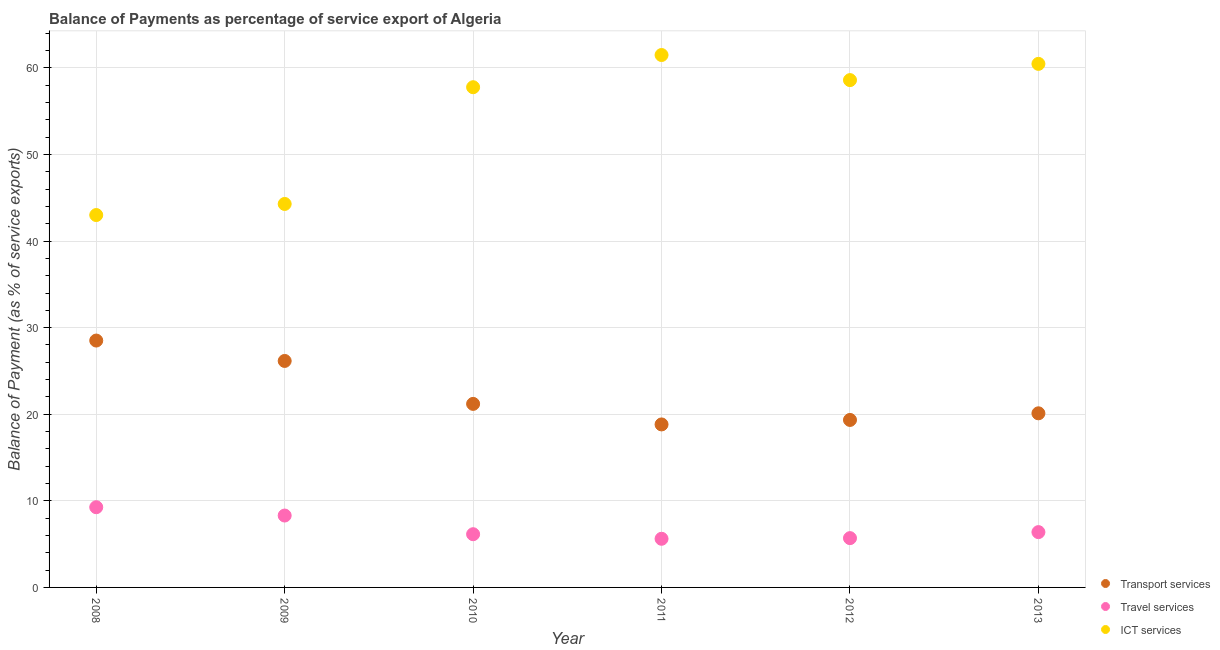How many different coloured dotlines are there?
Your response must be concise. 3. Is the number of dotlines equal to the number of legend labels?
Provide a short and direct response. Yes. What is the balance of payment of transport services in 2008?
Your answer should be very brief. 28.51. Across all years, what is the maximum balance of payment of transport services?
Keep it short and to the point. 28.51. Across all years, what is the minimum balance of payment of transport services?
Make the answer very short. 18.82. In which year was the balance of payment of transport services minimum?
Ensure brevity in your answer.  2011. What is the total balance of payment of transport services in the graph?
Your response must be concise. 134.13. What is the difference between the balance of payment of ict services in 2008 and that in 2010?
Provide a succinct answer. -14.76. What is the difference between the balance of payment of travel services in 2010 and the balance of payment of transport services in 2013?
Your answer should be compact. -13.96. What is the average balance of payment of travel services per year?
Provide a succinct answer. 6.9. In the year 2011, what is the difference between the balance of payment of ict services and balance of payment of transport services?
Make the answer very short. 42.66. What is the ratio of the balance of payment of travel services in 2012 to that in 2013?
Keep it short and to the point. 0.89. Is the balance of payment of transport services in 2011 less than that in 2012?
Your answer should be compact. Yes. Is the difference between the balance of payment of transport services in 2009 and 2010 greater than the difference between the balance of payment of travel services in 2009 and 2010?
Your answer should be compact. Yes. What is the difference between the highest and the second highest balance of payment of transport services?
Provide a short and direct response. 2.35. What is the difference between the highest and the lowest balance of payment of travel services?
Provide a succinct answer. 3.65. In how many years, is the balance of payment of travel services greater than the average balance of payment of travel services taken over all years?
Your answer should be very brief. 2. Is it the case that in every year, the sum of the balance of payment of transport services and balance of payment of travel services is greater than the balance of payment of ict services?
Give a very brief answer. No. How many dotlines are there?
Make the answer very short. 3. What is the difference between two consecutive major ticks on the Y-axis?
Your answer should be compact. 10. Does the graph contain grids?
Provide a succinct answer. Yes. What is the title of the graph?
Provide a short and direct response. Balance of Payments as percentage of service export of Algeria. Does "Agricultural raw materials" appear as one of the legend labels in the graph?
Offer a terse response. No. What is the label or title of the X-axis?
Your response must be concise. Year. What is the label or title of the Y-axis?
Your answer should be very brief. Balance of Payment (as % of service exports). What is the Balance of Payment (as % of service exports) in Transport services in 2008?
Your answer should be very brief. 28.51. What is the Balance of Payment (as % of service exports) in Travel services in 2008?
Make the answer very short. 9.26. What is the Balance of Payment (as % of service exports) of ICT services in 2008?
Your answer should be compact. 43. What is the Balance of Payment (as % of service exports) of Transport services in 2009?
Your response must be concise. 26.15. What is the Balance of Payment (as % of service exports) of Travel services in 2009?
Offer a very short reply. 8.3. What is the Balance of Payment (as % of service exports) in ICT services in 2009?
Your response must be concise. 44.28. What is the Balance of Payment (as % of service exports) of Transport services in 2010?
Your response must be concise. 21.2. What is the Balance of Payment (as % of service exports) of Travel services in 2010?
Ensure brevity in your answer.  6.15. What is the Balance of Payment (as % of service exports) in ICT services in 2010?
Give a very brief answer. 57.77. What is the Balance of Payment (as % of service exports) of Transport services in 2011?
Keep it short and to the point. 18.82. What is the Balance of Payment (as % of service exports) in Travel services in 2011?
Your answer should be very brief. 5.62. What is the Balance of Payment (as % of service exports) of ICT services in 2011?
Offer a terse response. 61.48. What is the Balance of Payment (as % of service exports) of Transport services in 2012?
Make the answer very short. 19.34. What is the Balance of Payment (as % of service exports) in Travel services in 2012?
Make the answer very short. 5.69. What is the Balance of Payment (as % of service exports) of ICT services in 2012?
Offer a very short reply. 58.59. What is the Balance of Payment (as % of service exports) in Transport services in 2013?
Make the answer very short. 20.11. What is the Balance of Payment (as % of service exports) in Travel services in 2013?
Offer a terse response. 6.39. What is the Balance of Payment (as % of service exports) in ICT services in 2013?
Offer a very short reply. 60.46. Across all years, what is the maximum Balance of Payment (as % of service exports) in Transport services?
Keep it short and to the point. 28.51. Across all years, what is the maximum Balance of Payment (as % of service exports) in Travel services?
Offer a very short reply. 9.26. Across all years, what is the maximum Balance of Payment (as % of service exports) of ICT services?
Keep it short and to the point. 61.48. Across all years, what is the minimum Balance of Payment (as % of service exports) in Transport services?
Provide a short and direct response. 18.82. Across all years, what is the minimum Balance of Payment (as % of service exports) in Travel services?
Provide a short and direct response. 5.62. Across all years, what is the minimum Balance of Payment (as % of service exports) of ICT services?
Offer a very short reply. 43. What is the total Balance of Payment (as % of service exports) of Transport services in the graph?
Offer a terse response. 134.13. What is the total Balance of Payment (as % of service exports) of Travel services in the graph?
Your answer should be compact. 41.41. What is the total Balance of Payment (as % of service exports) in ICT services in the graph?
Provide a short and direct response. 325.58. What is the difference between the Balance of Payment (as % of service exports) in Transport services in 2008 and that in 2009?
Your answer should be very brief. 2.35. What is the difference between the Balance of Payment (as % of service exports) in Travel services in 2008 and that in 2009?
Keep it short and to the point. 0.96. What is the difference between the Balance of Payment (as % of service exports) in ICT services in 2008 and that in 2009?
Give a very brief answer. -1.28. What is the difference between the Balance of Payment (as % of service exports) of Transport services in 2008 and that in 2010?
Your answer should be compact. 7.31. What is the difference between the Balance of Payment (as % of service exports) in Travel services in 2008 and that in 2010?
Your answer should be very brief. 3.12. What is the difference between the Balance of Payment (as % of service exports) of ICT services in 2008 and that in 2010?
Make the answer very short. -14.76. What is the difference between the Balance of Payment (as % of service exports) in Transport services in 2008 and that in 2011?
Give a very brief answer. 9.69. What is the difference between the Balance of Payment (as % of service exports) in Travel services in 2008 and that in 2011?
Ensure brevity in your answer.  3.65. What is the difference between the Balance of Payment (as % of service exports) of ICT services in 2008 and that in 2011?
Your answer should be compact. -18.48. What is the difference between the Balance of Payment (as % of service exports) of Transport services in 2008 and that in 2012?
Your answer should be very brief. 9.17. What is the difference between the Balance of Payment (as % of service exports) in Travel services in 2008 and that in 2012?
Your answer should be compact. 3.57. What is the difference between the Balance of Payment (as % of service exports) of ICT services in 2008 and that in 2012?
Your answer should be very brief. -15.58. What is the difference between the Balance of Payment (as % of service exports) of Transport services in 2008 and that in 2013?
Your answer should be very brief. 8.4. What is the difference between the Balance of Payment (as % of service exports) in Travel services in 2008 and that in 2013?
Provide a short and direct response. 2.88. What is the difference between the Balance of Payment (as % of service exports) in ICT services in 2008 and that in 2013?
Provide a succinct answer. -17.46. What is the difference between the Balance of Payment (as % of service exports) of Transport services in 2009 and that in 2010?
Your response must be concise. 4.96. What is the difference between the Balance of Payment (as % of service exports) of Travel services in 2009 and that in 2010?
Provide a succinct answer. 2.16. What is the difference between the Balance of Payment (as % of service exports) of ICT services in 2009 and that in 2010?
Ensure brevity in your answer.  -13.48. What is the difference between the Balance of Payment (as % of service exports) of Transport services in 2009 and that in 2011?
Offer a very short reply. 7.33. What is the difference between the Balance of Payment (as % of service exports) in Travel services in 2009 and that in 2011?
Ensure brevity in your answer.  2.68. What is the difference between the Balance of Payment (as % of service exports) of ICT services in 2009 and that in 2011?
Ensure brevity in your answer.  -17.2. What is the difference between the Balance of Payment (as % of service exports) in Transport services in 2009 and that in 2012?
Your answer should be very brief. 6.81. What is the difference between the Balance of Payment (as % of service exports) in Travel services in 2009 and that in 2012?
Offer a terse response. 2.61. What is the difference between the Balance of Payment (as % of service exports) of ICT services in 2009 and that in 2012?
Provide a short and direct response. -14.3. What is the difference between the Balance of Payment (as % of service exports) in Transport services in 2009 and that in 2013?
Your response must be concise. 6.05. What is the difference between the Balance of Payment (as % of service exports) of Travel services in 2009 and that in 2013?
Provide a short and direct response. 1.91. What is the difference between the Balance of Payment (as % of service exports) in ICT services in 2009 and that in 2013?
Your answer should be compact. -16.18. What is the difference between the Balance of Payment (as % of service exports) of Transport services in 2010 and that in 2011?
Your answer should be very brief. 2.37. What is the difference between the Balance of Payment (as % of service exports) in Travel services in 2010 and that in 2011?
Offer a terse response. 0.53. What is the difference between the Balance of Payment (as % of service exports) in ICT services in 2010 and that in 2011?
Make the answer very short. -3.72. What is the difference between the Balance of Payment (as % of service exports) of Transport services in 2010 and that in 2012?
Provide a short and direct response. 1.85. What is the difference between the Balance of Payment (as % of service exports) in Travel services in 2010 and that in 2012?
Ensure brevity in your answer.  0.45. What is the difference between the Balance of Payment (as % of service exports) in ICT services in 2010 and that in 2012?
Make the answer very short. -0.82. What is the difference between the Balance of Payment (as % of service exports) in Transport services in 2010 and that in 2013?
Provide a short and direct response. 1.09. What is the difference between the Balance of Payment (as % of service exports) in Travel services in 2010 and that in 2013?
Provide a short and direct response. -0.24. What is the difference between the Balance of Payment (as % of service exports) of ICT services in 2010 and that in 2013?
Your answer should be compact. -2.7. What is the difference between the Balance of Payment (as % of service exports) in Transport services in 2011 and that in 2012?
Make the answer very short. -0.52. What is the difference between the Balance of Payment (as % of service exports) of Travel services in 2011 and that in 2012?
Your answer should be very brief. -0.08. What is the difference between the Balance of Payment (as % of service exports) in ICT services in 2011 and that in 2012?
Provide a short and direct response. 2.9. What is the difference between the Balance of Payment (as % of service exports) in Transport services in 2011 and that in 2013?
Your answer should be compact. -1.28. What is the difference between the Balance of Payment (as % of service exports) in Travel services in 2011 and that in 2013?
Your response must be concise. -0.77. What is the difference between the Balance of Payment (as % of service exports) of ICT services in 2011 and that in 2013?
Provide a short and direct response. 1.02. What is the difference between the Balance of Payment (as % of service exports) of Transport services in 2012 and that in 2013?
Ensure brevity in your answer.  -0.77. What is the difference between the Balance of Payment (as % of service exports) of Travel services in 2012 and that in 2013?
Provide a short and direct response. -0.69. What is the difference between the Balance of Payment (as % of service exports) of ICT services in 2012 and that in 2013?
Ensure brevity in your answer.  -1.87. What is the difference between the Balance of Payment (as % of service exports) in Transport services in 2008 and the Balance of Payment (as % of service exports) in Travel services in 2009?
Provide a succinct answer. 20.21. What is the difference between the Balance of Payment (as % of service exports) of Transport services in 2008 and the Balance of Payment (as % of service exports) of ICT services in 2009?
Provide a short and direct response. -15.77. What is the difference between the Balance of Payment (as % of service exports) in Travel services in 2008 and the Balance of Payment (as % of service exports) in ICT services in 2009?
Offer a terse response. -35.02. What is the difference between the Balance of Payment (as % of service exports) in Transport services in 2008 and the Balance of Payment (as % of service exports) in Travel services in 2010?
Give a very brief answer. 22.36. What is the difference between the Balance of Payment (as % of service exports) of Transport services in 2008 and the Balance of Payment (as % of service exports) of ICT services in 2010?
Make the answer very short. -29.26. What is the difference between the Balance of Payment (as % of service exports) in Travel services in 2008 and the Balance of Payment (as % of service exports) in ICT services in 2010?
Keep it short and to the point. -48.5. What is the difference between the Balance of Payment (as % of service exports) of Transport services in 2008 and the Balance of Payment (as % of service exports) of Travel services in 2011?
Ensure brevity in your answer.  22.89. What is the difference between the Balance of Payment (as % of service exports) in Transport services in 2008 and the Balance of Payment (as % of service exports) in ICT services in 2011?
Offer a terse response. -32.97. What is the difference between the Balance of Payment (as % of service exports) of Travel services in 2008 and the Balance of Payment (as % of service exports) of ICT services in 2011?
Offer a very short reply. -52.22. What is the difference between the Balance of Payment (as % of service exports) of Transport services in 2008 and the Balance of Payment (as % of service exports) of Travel services in 2012?
Ensure brevity in your answer.  22.82. What is the difference between the Balance of Payment (as % of service exports) of Transport services in 2008 and the Balance of Payment (as % of service exports) of ICT services in 2012?
Keep it short and to the point. -30.08. What is the difference between the Balance of Payment (as % of service exports) of Travel services in 2008 and the Balance of Payment (as % of service exports) of ICT services in 2012?
Provide a short and direct response. -49.32. What is the difference between the Balance of Payment (as % of service exports) in Transport services in 2008 and the Balance of Payment (as % of service exports) in Travel services in 2013?
Provide a short and direct response. 22.12. What is the difference between the Balance of Payment (as % of service exports) in Transport services in 2008 and the Balance of Payment (as % of service exports) in ICT services in 2013?
Your answer should be compact. -31.95. What is the difference between the Balance of Payment (as % of service exports) of Travel services in 2008 and the Balance of Payment (as % of service exports) of ICT services in 2013?
Offer a terse response. -51.2. What is the difference between the Balance of Payment (as % of service exports) of Transport services in 2009 and the Balance of Payment (as % of service exports) of Travel services in 2010?
Provide a short and direct response. 20.01. What is the difference between the Balance of Payment (as % of service exports) in Transport services in 2009 and the Balance of Payment (as % of service exports) in ICT services in 2010?
Provide a short and direct response. -31.61. What is the difference between the Balance of Payment (as % of service exports) of Travel services in 2009 and the Balance of Payment (as % of service exports) of ICT services in 2010?
Make the answer very short. -49.46. What is the difference between the Balance of Payment (as % of service exports) in Transport services in 2009 and the Balance of Payment (as % of service exports) in Travel services in 2011?
Give a very brief answer. 20.54. What is the difference between the Balance of Payment (as % of service exports) in Transport services in 2009 and the Balance of Payment (as % of service exports) in ICT services in 2011?
Make the answer very short. -35.33. What is the difference between the Balance of Payment (as % of service exports) in Travel services in 2009 and the Balance of Payment (as % of service exports) in ICT services in 2011?
Give a very brief answer. -53.18. What is the difference between the Balance of Payment (as % of service exports) of Transport services in 2009 and the Balance of Payment (as % of service exports) of Travel services in 2012?
Your answer should be compact. 20.46. What is the difference between the Balance of Payment (as % of service exports) of Transport services in 2009 and the Balance of Payment (as % of service exports) of ICT services in 2012?
Your answer should be compact. -32.43. What is the difference between the Balance of Payment (as % of service exports) in Travel services in 2009 and the Balance of Payment (as % of service exports) in ICT services in 2012?
Your answer should be compact. -50.28. What is the difference between the Balance of Payment (as % of service exports) of Transport services in 2009 and the Balance of Payment (as % of service exports) of Travel services in 2013?
Give a very brief answer. 19.77. What is the difference between the Balance of Payment (as % of service exports) in Transport services in 2009 and the Balance of Payment (as % of service exports) in ICT services in 2013?
Your response must be concise. -34.31. What is the difference between the Balance of Payment (as % of service exports) in Travel services in 2009 and the Balance of Payment (as % of service exports) in ICT services in 2013?
Keep it short and to the point. -52.16. What is the difference between the Balance of Payment (as % of service exports) of Transport services in 2010 and the Balance of Payment (as % of service exports) of Travel services in 2011?
Provide a short and direct response. 15.58. What is the difference between the Balance of Payment (as % of service exports) in Transport services in 2010 and the Balance of Payment (as % of service exports) in ICT services in 2011?
Provide a short and direct response. -40.29. What is the difference between the Balance of Payment (as % of service exports) of Travel services in 2010 and the Balance of Payment (as % of service exports) of ICT services in 2011?
Provide a short and direct response. -55.34. What is the difference between the Balance of Payment (as % of service exports) in Transport services in 2010 and the Balance of Payment (as % of service exports) in Travel services in 2012?
Your response must be concise. 15.5. What is the difference between the Balance of Payment (as % of service exports) in Transport services in 2010 and the Balance of Payment (as % of service exports) in ICT services in 2012?
Offer a very short reply. -37.39. What is the difference between the Balance of Payment (as % of service exports) in Travel services in 2010 and the Balance of Payment (as % of service exports) in ICT services in 2012?
Provide a succinct answer. -52.44. What is the difference between the Balance of Payment (as % of service exports) in Transport services in 2010 and the Balance of Payment (as % of service exports) in Travel services in 2013?
Offer a terse response. 14.81. What is the difference between the Balance of Payment (as % of service exports) of Transport services in 2010 and the Balance of Payment (as % of service exports) of ICT services in 2013?
Keep it short and to the point. -39.27. What is the difference between the Balance of Payment (as % of service exports) of Travel services in 2010 and the Balance of Payment (as % of service exports) of ICT services in 2013?
Keep it short and to the point. -54.32. What is the difference between the Balance of Payment (as % of service exports) in Transport services in 2011 and the Balance of Payment (as % of service exports) in Travel services in 2012?
Offer a very short reply. 13.13. What is the difference between the Balance of Payment (as % of service exports) in Transport services in 2011 and the Balance of Payment (as % of service exports) in ICT services in 2012?
Your response must be concise. -39.76. What is the difference between the Balance of Payment (as % of service exports) in Travel services in 2011 and the Balance of Payment (as % of service exports) in ICT services in 2012?
Make the answer very short. -52.97. What is the difference between the Balance of Payment (as % of service exports) in Transport services in 2011 and the Balance of Payment (as % of service exports) in Travel services in 2013?
Your answer should be very brief. 12.44. What is the difference between the Balance of Payment (as % of service exports) in Transport services in 2011 and the Balance of Payment (as % of service exports) in ICT services in 2013?
Your answer should be very brief. -41.64. What is the difference between the Balance of Payment (as % of service exports) of Travel services in 2011 and the Balance of Payment (as % of service exports) of ICT services in 2013?
Ensure brevity in your answer.  -54.84. What is the difference between the Balance of Payment (as % of service exports) in Transport services in 2012 and the Balance of Payment (as % of service exports) in Travel services in 2013?
Your response must be concise. 12.95. What is the difference between the Balance of Payment (as % of service exports) of Transport services in 2012 and the Balance of Payment (as % of service exports) of ICT services in 2013?
Offer a very short reply. -41.12. What is the difference between the Balance of Payment (as % of service exports) of Travel services in 2012 and the Balance of Payment (as % of service exports) of ICT services in 2013?
Your answer should be very brief. -54.77. What is the average Balance of Payment (as % of service exports) of Transport services per year?
Make the answer very short. 22.36. What is the average Balance of Payment (as % of service exports) in Travel services per year?
Give a very brief answer. 6.9. What is the average Balance of Payment (as % of service exports) in ICT services per year?
Give a very brief answer. 54.26. In the year 2008, what is the difference between the Balance of Payment (as % of service exports) in Transport services and Balance of Payment (as % of service exports) in Travel services?
Make the answer very short. 19.25. In the year 2008, what is the difference between the Balance of Payment (as % of service exports) of Transport services and Balance of Payment (as % of service exports) of ICT services?
Offer a terse response. -14.49. In the year 2008, what is the difference between the Balance of Payment (as % of service exports) in Travel services and Balance of Payment (as % of service exports) in ICT services?
Give a very brief answer. -33.74. In the year 2009, what is the difference between the Balance of Payment (as % of service exports) in Transport services and Balance of Payment (as % of service exports) in Travel services?
Offer a very short reply. 17.85. In the year 2009, what is the difference between the Balance of Payment (as % of service exports) of Transport services and Balance of Payment (as % of service exports) of ICT services?
Keep it short and to the point. -18.13. In the year 2009, what is the difference between the Balance of Payment (as % of service exports) of Travel services and Balance of Payment (as % of service exports) of ICT services?
Provide a succinct answer. -35.98. In the year 2010, what is the difference between the Balance of Payment (as % of service exports) of Transport services and Balance of Payment (as % of service exports) of Travel services?
Your answer should be compact. 15.05. In the year 2010, what is the difference between the Balance of Payment (as % of service exports) of Transport services and Balance of Payment (as % of service exports) of ICT services?
Provide a succinct answer. -36.57. In the year 2010, what is the difference between the Balance of Payment (as % of service exports) of Travel services and Balance of Payment (as % of service exports) of ICT services?
Give a very brief answer. -51.62. In the year 2011, what is the difference between the Balance of Payment (as % of service exports) in Transport services and Balance of Payment (as % of service exports) in Travel services?
Provide a succinct answer. 13.21. In the year 2011, what is the difference between the Balance of Payment (as % of service exports) of Transport services and Balance of Payment (as % of service exports) of ICT services?
Give a very brief answer. -42.66. In the year 2011, what is the difference between the Balance of Payment (as % of service exports) of Travel services and Balance of Payment (as % of service exports) of ICT services?
Offer a very short reply. -55.87. In the year 2012, what is the difference between the Balance of Payment (as % of service exports) in Transport services and Balance of Payment (as % of service exports) in Travel services?
Ensure brevity in your answer.  13.65. In the year 2012, what is the difference between the Balance of Payment (as % of service exports) of Transport services and Balance of Payment (as % of service exports) of ICT services?
Give a very brief answer. -39.24. In the year 2012, what is the difference between the Balance of Payment (as % of service exports) in Travel services and Balance of Payment (as % of service exports) in ICT services?
Keep it short and to the point. -52.89. In the year 2013, what is the difference between the Balance of Payment (as % of service exports) of Transport services and Balance of Payment (as % of service exports) of Travel services?
Ensure brevity in your answer.  13.72. In the year 2013, what is the difference between the Balance of Payment (as % of service exports) in Transport services and Balance of Payment (as % of service exports) in ICT services?
Provide a succinct answer. -40.35. In the year 2013, what is the difference between the Balance of Payment (as % of service exports) of Travel services and Balance of Payment (as % of service exports) of ICT services?
Your answer should be compact. -54.07. What is the ratio of the Balance of Payment (as % of service exports) of Transport services in 2008 to that in 2009?
Keep it short and to the point. 1.09. What is the ratio of the Balance of Payment (as % of service exports) of Travel services in 2008 to that in 2009?
Offer a very short reply. 1.12. What is the ratio of the Balance of Payment (as % of service exports) of ICT services in 2008 to that in 2009?
Offer a very short reply. 0.97. What is the ratio of the Balance of Payment (as % of service exports) in Transport services in 2008 to that in 2010?
Your answer should be very brief. 1.35. What is the ratio of the Balance of Payment (as % of service exports) of Travel services in 2008 to that in 2010?
Provide a succinct answer. 1.51. What is the ratio of the Balance of Payment (as % of service exports) in ICT services in 2008 to that in 2010?
Your answer should be compact. 0.74. What is the ratio of the Balance of Payment (as % of service exports) of Transport services in 2008 to that in 2011?
Your answer should be compact. 1.51. What is the ratio of the Balance of Payment (as % of service exports) in Travel services in 2008 to that in 2011?
Provide a succinct answer. 1.65. What is the ratio of the Balance of Payment (as % of service exports) of ICT services in 2008 to that in 2011?
Ensure brevity in your answer.  0.7. What is the ratio of the Balance of Payment (as % of service exports) in Transport services in 2008 to that in 2012?
Your answer should be compact. 1.47. What is the ratio of the Balance of Payment (as % of service exports) in Travel services in 2008 to that in 2012?
Keep it short and to the point. 1.63. What is the ratio of the Balance of Payment (as % of service exports) in ICT services in 2008 to that in 2012?
Your answer should be compact. 0.73. What is the ratio of the Balance of Payment (as % of service exports) in Transport services in 2008 to that in 2013?
Your answer should be very brief. 1.42. What is the ratio of the Balance of Payment (as % of service exports) in Travel services in 2008 to that in 2013?
Your answer should be very brief. 1.45. What is the ratio of the Balance of Payment (as % of service exports) in ICT services in 2008 to that in 2013?
Ensure brevity in your answer.  0.71. What is the ratio of the Balance of Payment (as % of service exports) in Transport services in 2009 to that in 2010?
Your answer should be compact. 1.23. What is the ratio of the Balance of Payment (as % of service exports) in Travel services in 2009 to that in 2010?
Your response must be concise. 1.35. What is the ratio of the Balance of Payment (as % of service exports) of ICT services in 2009 to that in 2010?
Give a very brief answer. 0.77. What is the ratio of the Balance of Payment (as % of service exports) in Transport services in 2009 to that in 2011?
Provide a succinct answer. 1.39. What is the ratio of the Balance of Payment (as % of service exports) of Travel services in 2009 to that in 2011?
Offer a terse response. 1.48. What is the ratio of the Balance of Payment (as % of service exports) of ICT services in 2009 to that in 2011?
Your answer should be compact. 0.72. What is the ratio of the Balance of Payment (as % of service exports) of Transport services in 2009 to that in 2012?
Provide a succinct answer. 1.35. What is the ratio of the Balance of Payment (as % of service exports) in Travel services in 2009 to that in 2012?
Your response must be concise. 1.46. What is the ratio of the Balance of Payment (as % of service exports) of ICT services in 2009 to that in 2012?
Provide a succinct answer. 0.76. What is the ratio of the Balance of Payment (as % of service exports) in Transport services in 2009 to that in 2013?
Your answer should be very brief. 1.3. What is the ratio of the Balance of Payment (as % of service exports) of Travel services in 2009 to that in 2013?
Provide a short and direct response. 1.3. What is the ratio of the Balance of Payment (as % of service exports) of ICT services in 2009 to that in 2013?
Give a very brief answer. 0.73. What is the ratio of the Balance of Payment (as % of service exports) in Transport services in 2010 to that in 2011?
Provide a short and direct response. 1.13. What is the ratio of the Balance of Payment (as % of service exports) of Travel services in 2010 to that in 2011?
Ensure brevity in your answer.  1.09. What is the ratio of the Balance of Payment (as % of service exports) in ICT services in 2010 to that in 2011?
Your answer should be very brief. 0.94. What is the ratio of the Balance of Payment (as % of service exports) in Transport services in 2010 to that in 2012?
Provide a succinct answer. 1.1. What is the ratio of the Balance of Payment (as % of service exports) of Travel services in 2010 to that in 2012?
Offer a terse response. 1.08. What is the ratio of the Balance of Payment (as % of service exports) of Transport services in 2010 to that in 2013?
Offer a very short reply. 1.05. What is the ratio of the Balance of Payment (as % of service exports) of Travel services in 2010 to that in 2013?
Ensure brevity in your answer.  0.96. What is the ratio of the Balance of Payment (as % of service exports) in ICT services in 2010 to that in 2013?
Provide a succinct answer. 0.96. What is the ratio of the Balance of Payment (as % of service exports) of Transport services in 2011 to that in 2012?
Offer a terse response. 0.97. What is the ratio of the Balance of Payment (as % of service exports) of ICT services in 2011 to that in 2012?
Ensure brevity in your answer.  1.05. What is the ratio of the Balance of Payment (as % of service exports) of Transport services in 2011 to that in 2013?
Give a very brief answer. 0.94. What is the ratio of the Balance of Payment (as % of service exports) in Travel services in 2011 to that in 2013?
Offer a terse response. 0.88. What is the ratio of the Balance of Payment (as % of service exports) in ICT services in 2011 to that in 2013?
Keep it short and to the point. 1.02. What is the ratio of the Balance of Payment (as % of service exports) in Transport services in 2012 to that in 2013?
Provide a succinct answer. 0.96. What is the ratio of the Balance of Payment (as % of service exports) in Travel services in 2012 to that in 2013?
Provide a succinct answer. 0.89. What is the ratio of the Balance of Payment (as % of service exports) of ICT services in 2012 to that in 2013?
Provide a succinct answer. 0.97. What is the difference between the highest and the second highest Balance of Payment (as % of service exports) of Transport services?
Keep it short and to the point. 2.35. What is the difference between the highest and the second highest Balance of Payment (as % of service exports) in Travel services?
Your answer should be compact. 0.96. What is the difference between the highest and the second highest Balance of Payment (as % of service exports) of ICT services?
Your response must be concise. 1.02. What is the difference between the highest and the lowest Balance of Payment (as % of service exports) of Transport services?
Your answer should be very brief. 9.69. What is the difference between the highest and the lowest Balance of Payment (as % of service exports) of Travel services?
Give a very brief answer. 3.65. What is the difference between the highest and the lowest Balance of Payment (as % of service exports) of ICT services?
Give a very brief answer. 18.48. 